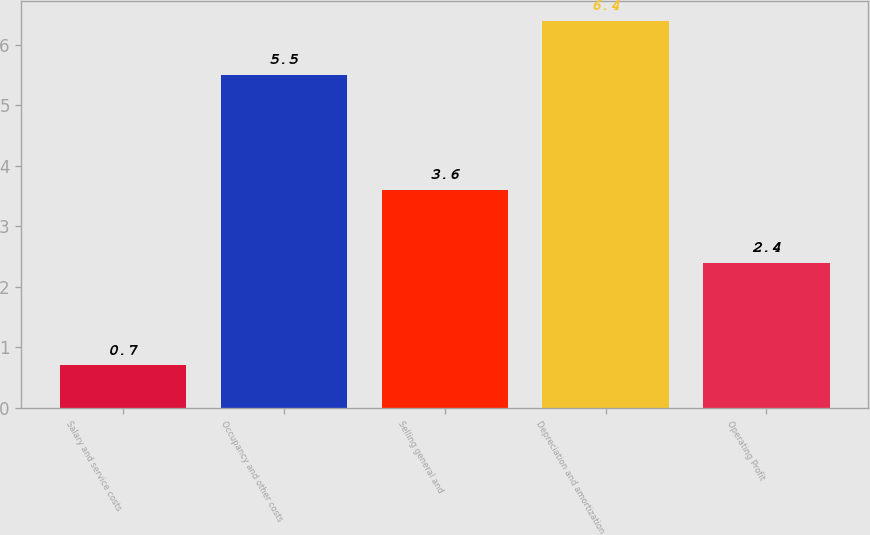<chart> <loc_0><loc_0><loc_500><loc_500><bar_chart><fcel>Salary and service costs<fcel>Occupancy and other costs<fcel>Selling general and<fcel>Depreciation and amortization<fcel>Operating Profit<nl><fcel>0.7<fcel>5.5<fcel>3.6<fcel>6.4<fcel>2.4<nl></chart> 